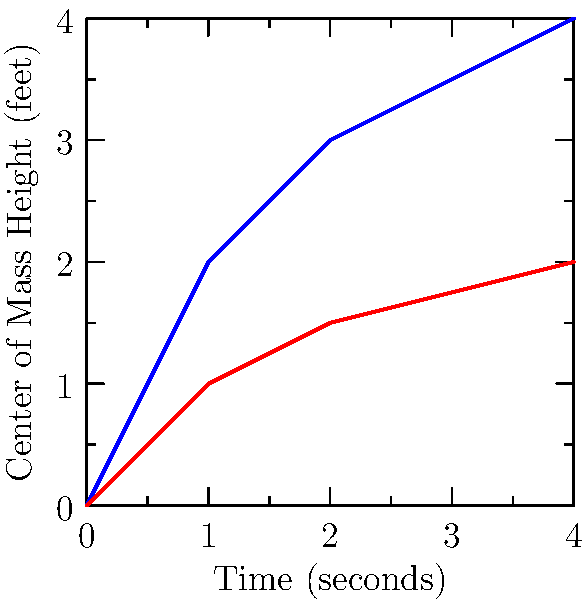Based on the graph showing the center of mass height over time for two different dance poses, which pose requires more balance control and why? To determine which pose requires more balance control, we need to analyze the center of mass (COM) height and its changes over time:

1. Arabesque (blue line):
   - The COM starts at 0 feet and rises rapidly to about 4 feet.
   - The curve shows a steep increase, indicating a quick elevation of the body.
   - The final position is high and relatively stable (flat curve at the end).

2. Plié (red line):
   - The COM starts at 0 feet and rises gradually to about 2 feet.
   - The curve shows a more gradual increase, indicating a slower change in body position.
   - The final position is lower than the Arabesque.

3. Balance control analysis:
   - A higher COM generally requires more balance control, as it increases the potential for instability.
   - Rapid changes in COM height (as seen in Arabesque) also challenge balance more than gradual changes.
   - The Arabesque pose ends with a higher COM, which is inherently less stable than a lower position.

4. Biomechanical considerations:
   - In Arabesque, one leg is typically extended behind the body, reducing the base of support.
   - The higher COM in Arabesque creates a longer moment arm, increasing the torque that must be controlled by the supporting muscles.
   - Plié involves bending the knees while keeping both feet on the ground, providing a more stable base of support.

Therefore, the Arabesque pose requires more balance control due to its higher final COM, rapid elevation, and reduced base of support compared to the Plié.
Answer: Arabesque, due to higher and rapidly elevated center of mass. 